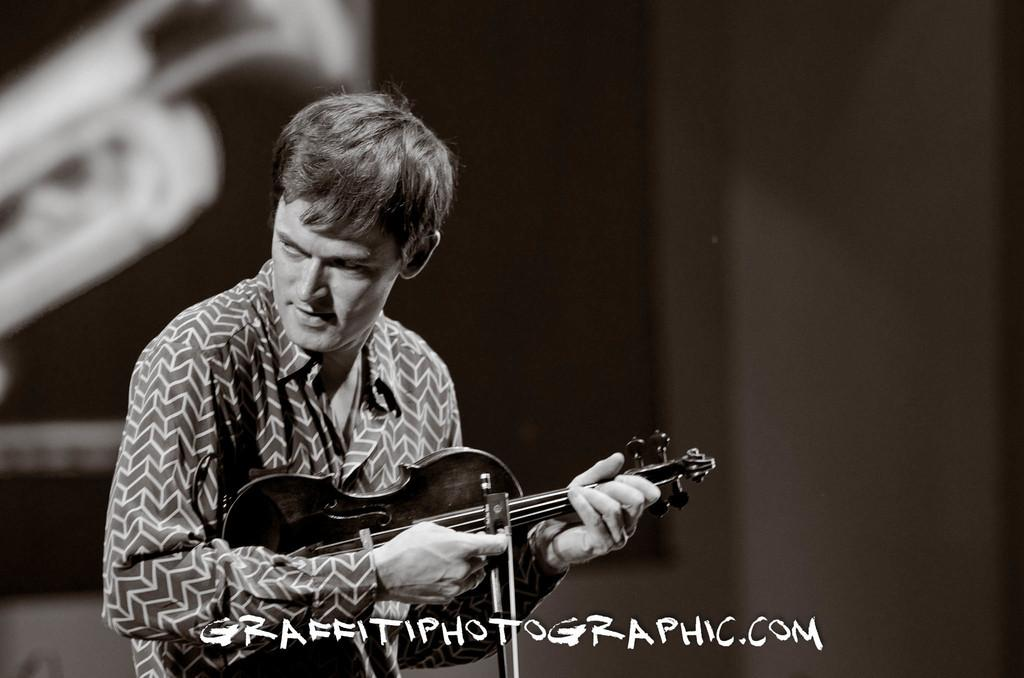What is the main subject of the image? There is a person in the image. What is the person doing in the image? The person is standing and playing a guitar. What color is the orange that the queen is holding in the image? There is no orange or queen present in the image; it features a person playing a guitar. 